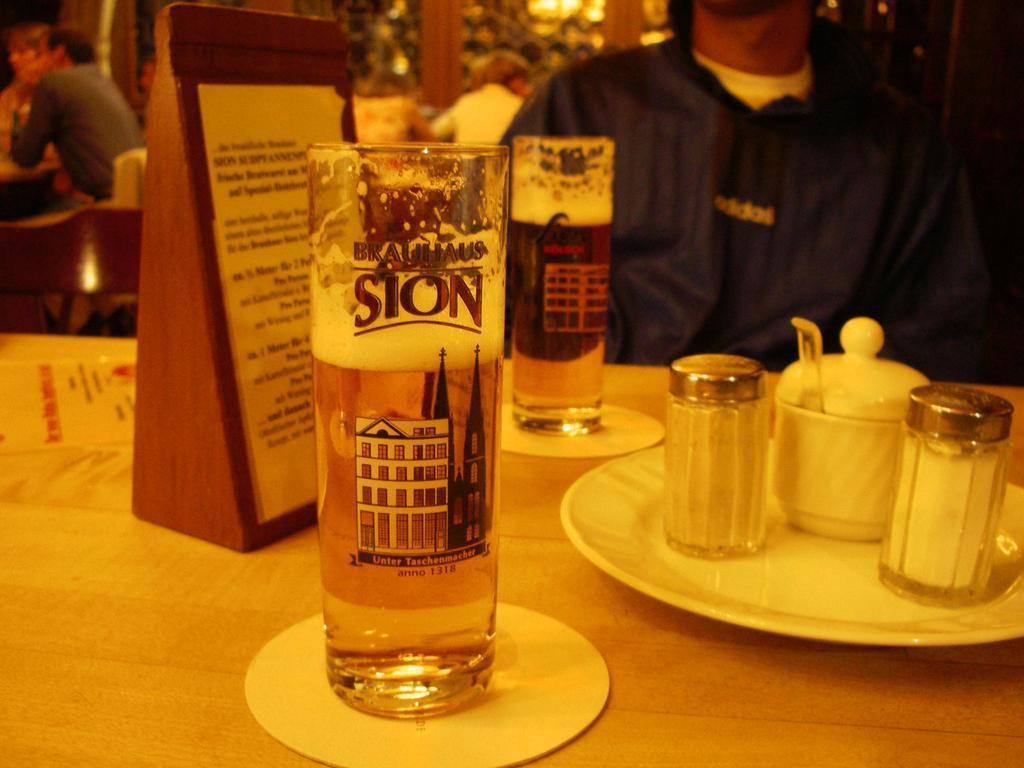<image>
Give a short and clear explanation of the subsequent image. A tall glass withBrauhaus Sion printed on it about two thirds full of liquid on a table. 